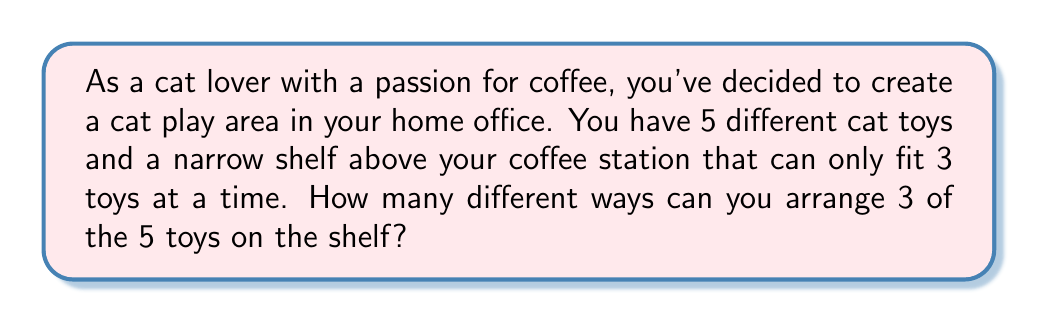What is the answer to this math problem? This problem can be solved using the concept of permutations. We need to select 3 toys out of 5 and arrange them on the shelf. The order matters because we're arranging them, not just selecting them.

Let's break it down step-by-step:

1) First, we need to choose 3 toys out of 5. This is a combination problem, denoted as $\binom{5}{3}$ or $C(5,3)$.

2) The number of ways to choose 3 items from 5 is:

   $$\binom{5}{3} = \frac{5!}{3!(5-3)!} = \frac{5!}{3!2!} = 10$$

3) Now, for each of these 10 combinations, we need to arrange the 3 chosen toys. This is a permutation of 3 items, which is simply 3!.

4) By the multiplication principle, the total number of ways to arrange 3 toys out of 5 on the shelf is:

   $$\binom{5}{3} \times 3! = 10 \times 6 = 60$$

This result is also known as a permutation of 5 items taken 3 at a time, denoted as $P(5,3)$ or ${}^5P_3$.

We can calculate this directly:

$$P(5,3) = \frac{5!}{(5-3)!} = \frac{5!}{2!} = 60$$

Thus, there are 60 different ways to arrange 3 of the 5 cat toys on the shelf above your coffee station.
Answer: 60 ways 